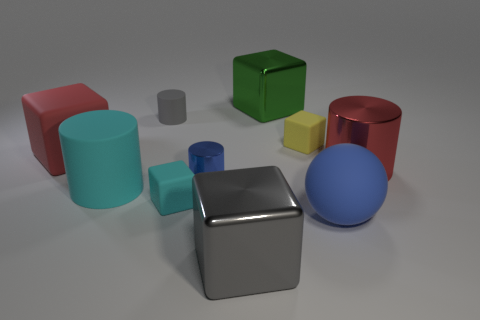Subtract 2 cubes. How many cubes are left? 3 Subtract all cyan blocks. How many blocks are left? 4 Subtract all small yellow blocks. How many blocks are left? 4 Subtract all purple blocks. Subtract all brown cylinders. How many blocks are left? 5 Subtract all cylinders. How many objects are left? 6 Subtract 0 green cylinders. How many objects are left? 10 Subtract all small brown rubber cylinders. Subtract all blue rubber things. How many objects are left? 9 Add 2 blue things. How many blue things are left? 4 Add 3 tiny purple rubber cylinders. How many tiny purple rubber cylinders exist? 3 